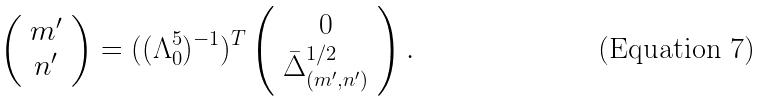<formula> <loc_0><loc_0><loc_500><loc_500>\left ( \begin{array} { c } m ^ { \prime } \\ n ^ { \prime } \end{array} \right ) = ( ( \Lambda _ { 0 } ^ { 5 } ) ^ { - 1 } ) ^ { T } \left ( \begin{array} { c } 0 \\ \bar { \Delta } _ { ( m ^ { \prime } , n ^ { \prime } ) } ^ { 1 / 2 } \end{array} \right ) .</formula> 